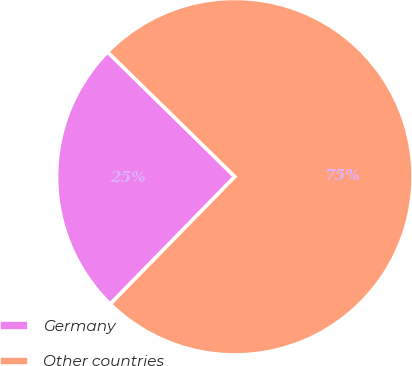Convert chart to OTSL. <chart><loc_0><loc_0><loc_500><loc_500><pie_chart><fcel>Germany<fcel>Other countries<nl><fcel>25.02%<fcel>74.98%<nl></chart> 